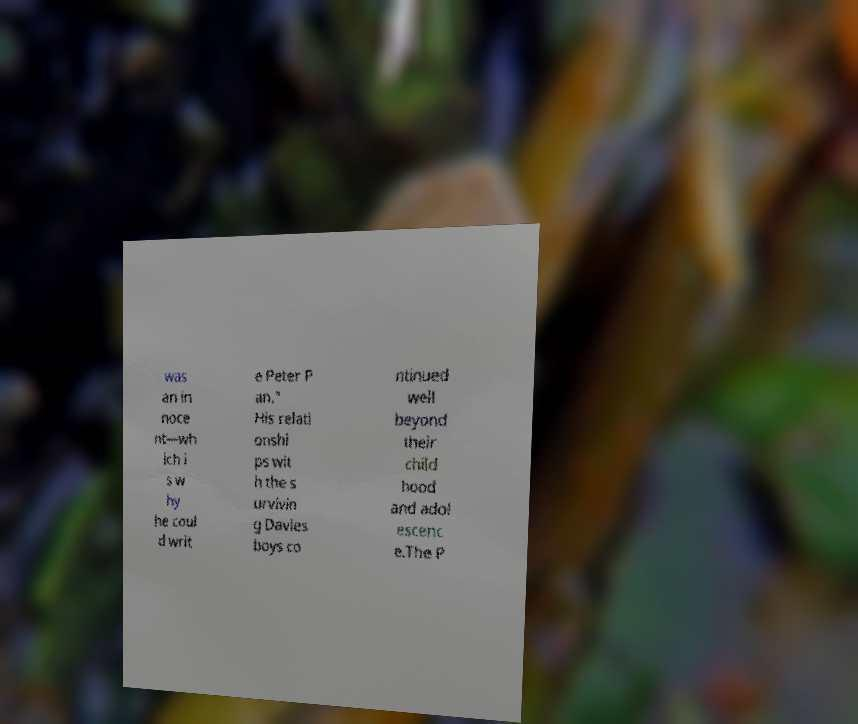Can you accurately transcribe the text from the provided image for me? was an in noce nt—wh ich i s w hy he coul d writ e Peter P an." His relati onshi ps wit h the s urvivin g Davies boys co ntinued well beyond their child hood and adol escenc e.The P 